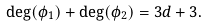Convert formula to latex. <formula><loc_0><loc_0><loc_500><loc_500>\deg ( \phi _ { 1 } ) + \deg ( \phi _ { 2 } ) = 3 d + 3 .</formula> 